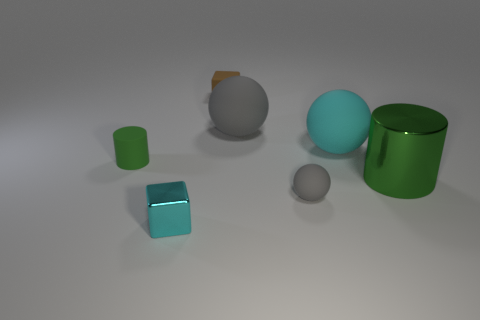What material is the other green thing that is the same shape as the large metallic thing?
Offer a terse response. Rubber. There is a green cylinder on the right side of the cyan shiny block; how many cyan things are left of it?
Ensure brevity in your answer.  2. Do the big metal cylinder and the cylinder that is left of the rubber cube have the same color?
Provide a short and direct response. Yes. What number of green objects are the same shape as the small brown matte thing?
Offer a very short reply. 0. There is a object to the left of the metal block; what is its material?
Offer a very short reply. Rubber. There is a small matte thing that is behind the green matte object; does it have the same shape as the tiny cyan shiny object?
Your answer should be very brief. Yes. Are there any matte blocks of the same size as the metallic cube?
Keep it short and to the point. Yes. Does the large metallic object have the same shape as the large object behind the big cyan ball?
Provide a succinct answer. No. There is a object that is the same color as the shiny block; what is its shape?
Provide a succinct answer. Sphere. Is the number of tiny green rubber objects right of the shiny block less than the number of brown metallic cylinders?
Provide a succinct answer. No. 